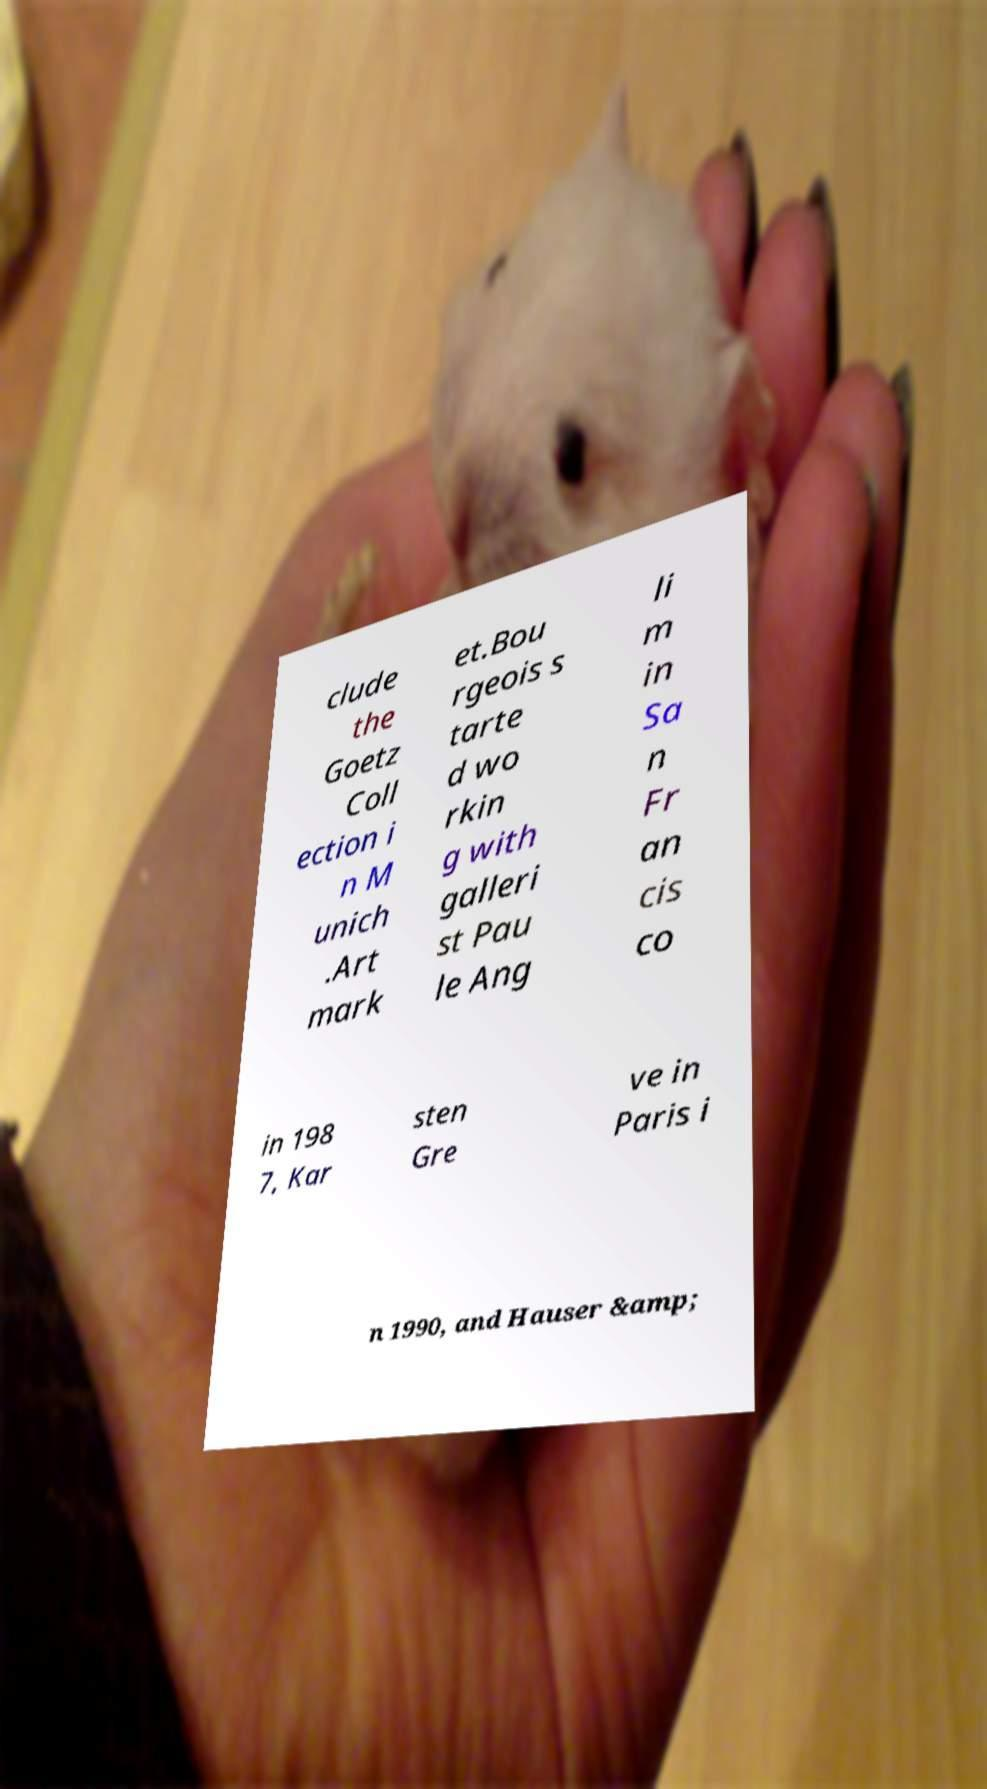For documentation purposes, I need the text within this image transcribed. Could you provide that? clude the Goetz Coll ection i n M unich .Art mark et.Bou rgeois s tarte d wo rkin g with galleri st Pau le Ang li m in Sa n Fr an cis co in 198 7, Kar sten Gre ve in Paris i n 1990, and Hauser &amp; 